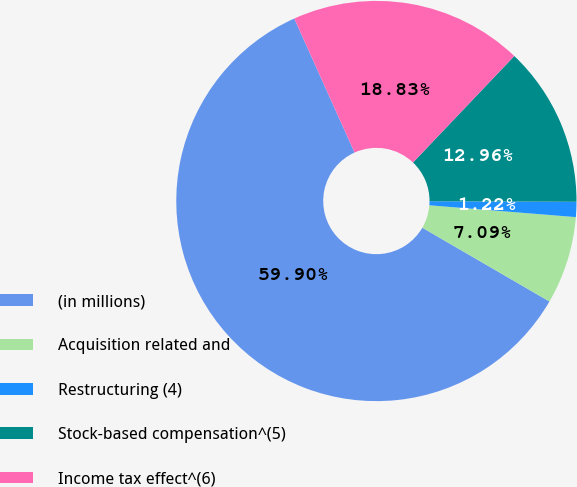Convert chart. <chart><loc_0><loc_0><loc_500><loc_500><pie_chart><fcel>(in millions)<fcel>Acquisition related and<fcel>Restructuring (4)<fcel>Stock-based compensation^(5)<fcel>Income tax effect^(6)<nl><fcel>59.9%<fcel>7.09%<fcel>1.22%<fcel>12.96%<fcel>18.83%<nl></chart> 